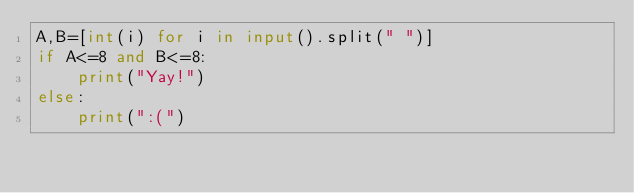Convert code to text. <code><loc_0><loc_0><loc_500><loc_500><_Python_>A,B=[int(i) for i in input().split(" ")]
if A<=8 and B<=8:
    print("Yay!")
else:
    print(":(")
</code> 